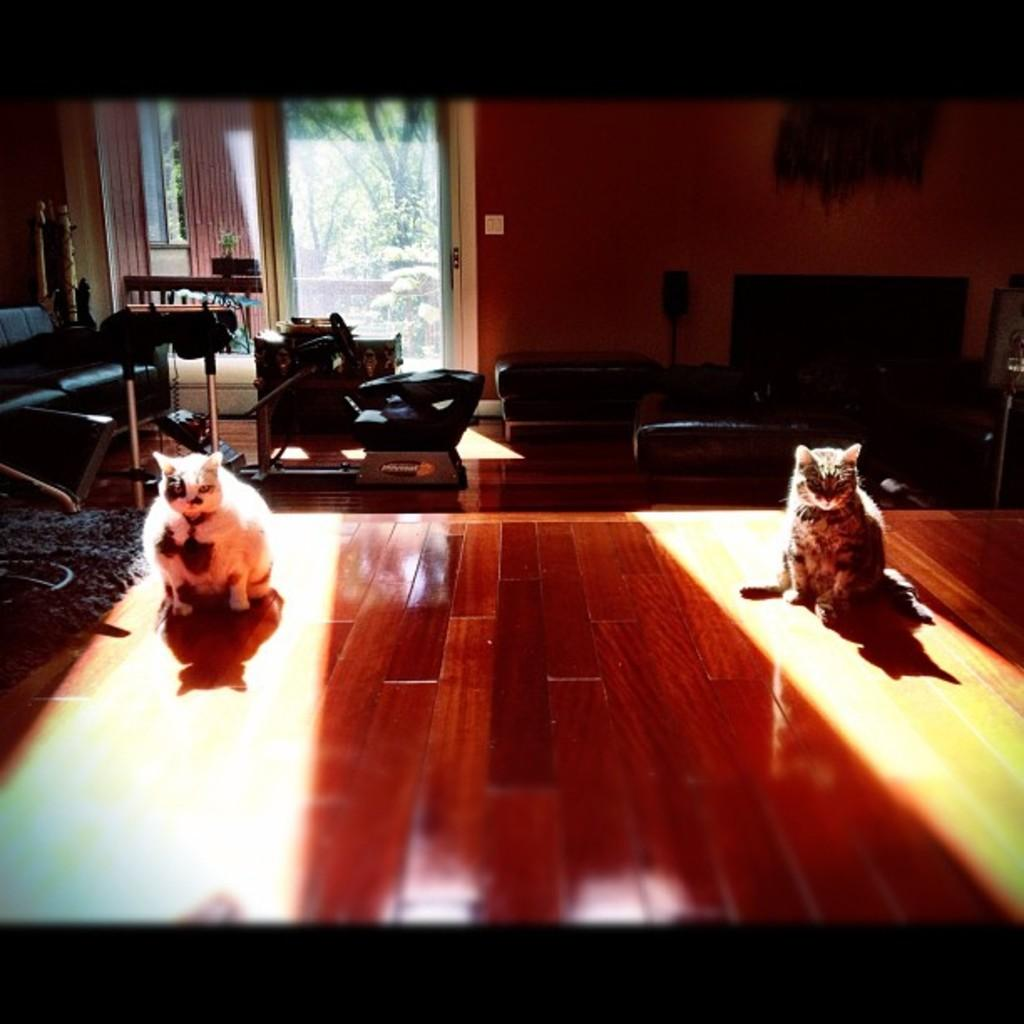What animals are on the table in the image? There are cats on the table in the image. What type of furniture can be seen in the distance? There are couches in the distance. What is on the floor in the image? The floor has a carpet. What type of door is present in the image? There is a glass door in the image. What can be seen through the glass door? Trees are visible through the glass door. What type of plant is on the table? There is a plant on the table. How does the cat start the engine in the image? There is no engine present in the image, and cats do not have the ability to start engines. What type of adjustment does the plant need in the image? The plant does not appear to need any adjustment in the image, as it is already on the table. 